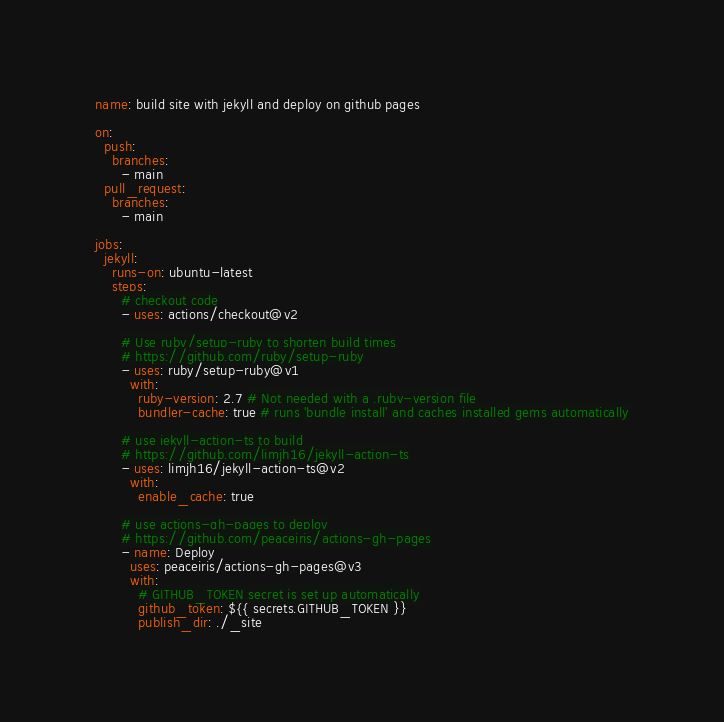<code> <loc_0><loc_0><loc_500><loc_500><_YAML_>name: build site with jekyll and deploy on github pages

on:
  push: 
    branches: 
      - main
  pull_request:
    branches: 
      - main

jobs:
  jekyll:
    runs-on: ubuntu-latest
    steps:
      # checkout code
      - uses: actions/checkout@v2

      # Use ruby/setup-ruby to shorten build times
      # https://github.com/ruby/setup-ruby
      - uses: ruby/setup-ruby@v1
        with:
          ruby-version: 2.7 # Not needed with a .ruby-version file
          bundler-cache: true # runs 'bundle install' and caches installed gems automatically

      # use jekyll-action-ts to build
      # https://github.com/limjh16/jekyll-action-ts
      - uses: limjh16/jekyll-action-ts@v2
        with:
          enable_cache: true

      # use actions-gh-pages to deploy
      # https://github.com/peaceiris/actions-gh-pages
      - name: Deploy
        uses: peaceiris/actions-gh-pages@v3
        with:
          # GITHUB_TOKEN secret is set up automatically
          github_token: ${{ secrets.GITHUB_TOKEN }}
          publish_dir: ./_site
</code> 